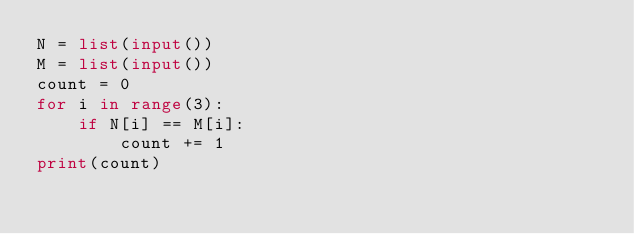Convert code to text. <code><loc_0><loc_0><loc_500><loc_500><_Python_>N = list(input())
M = list(input())
count = 0
for i in range(3):
    if N[i] == M[i]:
        count += 1
print(count)</code> 